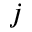Convert formula to latex. <formula><loc_0><loc_0><loc_500><loc_500>j</formula> 